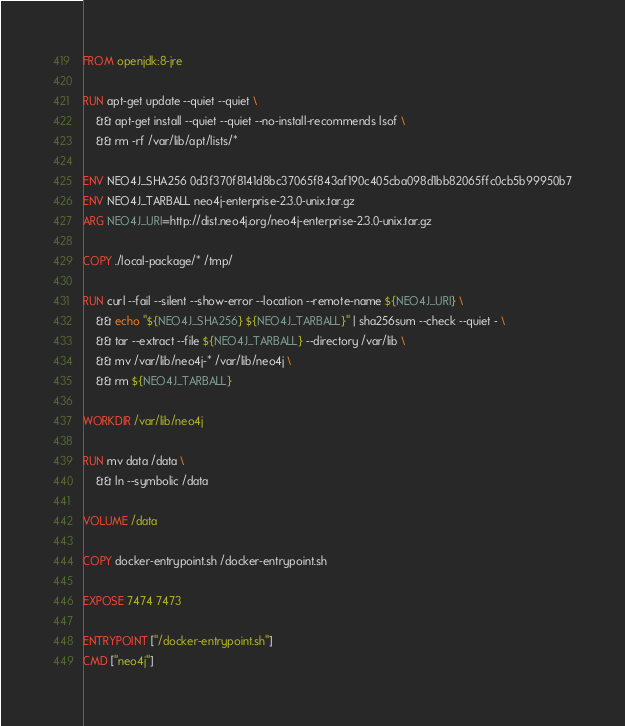<code> <loc_0><loc_0><loc_500><loc_500><_Dockerfile_>FROM openjdk:8-jre

RUN apt-get update --quiet --quiet \
    && apt-get install --quiet --quiet --no-install-recommends lsof \
    && rm -rf /var/lib/apt/lists/*

ENV NEO4J_SHA256 0d3f370f8141d8bc37065f843af190c405cba098d1bb82065ffc0cb5b99950b7
ENV NEO4J_TARBALL neo4j-enterprise-2.3.0-unix.tar.gz
ARG NEO4J_URI=http://dist.neo4j.org/neo4j-enterprise-2.3.0-unix.tar.gz

COPY ./local-package/* /tmp/

RUN curl --fail --silent --show-error --location --remote-name ${NEO4J_URI} \
    && echo "${NEO4J_SHA256} ${NEO4J_TARBALL}" | sha256sum --check --quiet - \
    && tar --extract --file ${NEO4J_TARBALL} --directory /var/lib \
    && mv /var/lib/neo4j-* /var/lib/neo4j \
    && rm ${NEO4J_TARBALL}

WORKDIR /var/lib/neo4j

RUN mv data /data \
    && ln --symbolic /data

VOLUME /data

COPY docker-entrypoint.sh /docker-entrypoint.sh

EXPOSE 7474 7473

ENTRYPOINT ["/docker-entrypoint.sh"]
CMD ["neo4j"]
</code> 